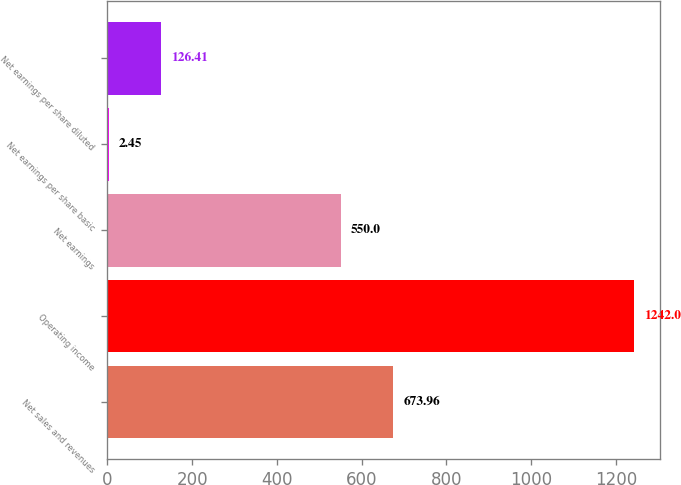Convert chart. <chart><loc_0><loc_0><loc_500><loc_500><bar_chart><fcel>Net sales and revenues<fcel>Operating income<fcel>Net earnings<fcel>Net earnings per share basic<fcel>Net earnings per share diluted<nl><fcel>673.96<fcel>1242<fcel>550<fcel>2.45<fcel>126.41<nl></chart> 